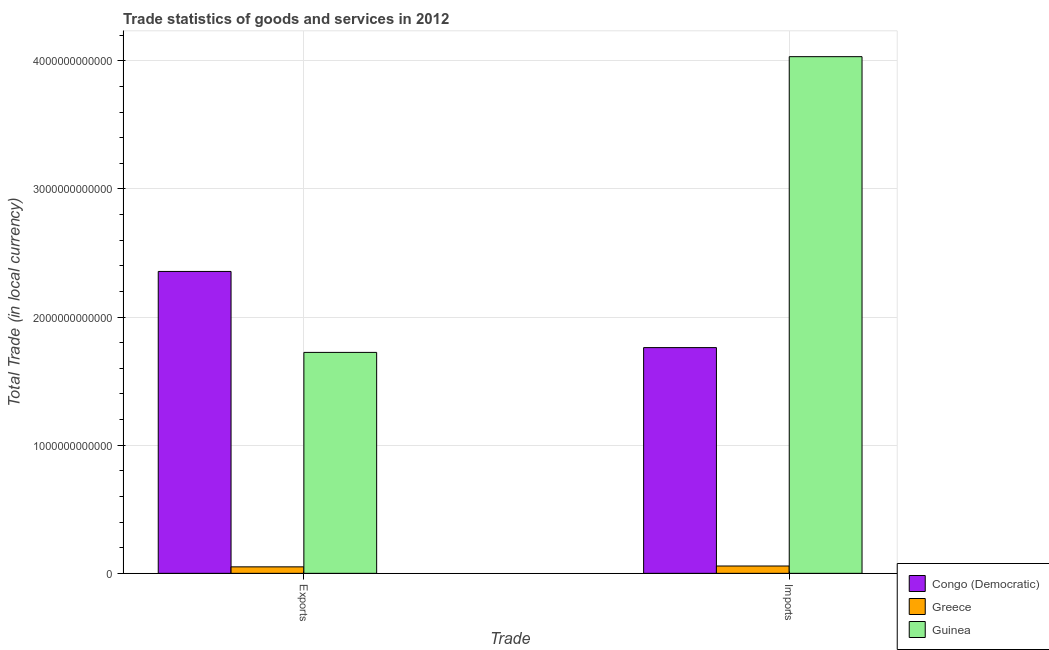How many different coloured bars are there?
Provide a short and direct response. 3. Are the number of bars per tick equal to the number of legend labels?
Provide a succinct answer. Yes. How many bars are there on the 1st tick from the left?
Give a very brief answer. 3. What is the label of the 2nd group of bars from the left?
Provide a succinct answer. Imports. What is the imports of goods and services in Greece?
Provide a succinct answer. 5.72e+1. Across all countries, what is the maximum imports of goods and services?
Your response must be concise. 4.03e+12. Across all countries, what is the minimum imports of goods and services?
Ensure brevity in your answer.  5.72e+1. In which country was the imports of goods and services maximum?
Offer a very short reply. Guinea. In which country was the export of goods and services minimum?
Offer a very short reply. Greece. What is the total imports of goods and services in the graph?
Provide a succinct answer. 5.85e+12. What is the difference between the imports of goods and services in Greece and that in Congo (Democratic)?
Give a very brief answer. -1.70e+12. What is the difference between the export of goods and services in Greece and the imports of goods and services in Guinea?
Offer a very short reply. -3.98e+12. What is the average export of goods and services per country?
Keep it short and to the point. 1.38e+12. What is the difference between the export of goods and services and imports of goods and services in Guinea?
Keep it short and to the point. -2.31e+12. In how many countries, is the export of goods and services greater than 2000000000000 LCU?
Keep it short and to the point. 1. What is the ratio of the export of goods and services in Greece to that in Congo (Democratic)?
Provide a short and direct response. 0.02. In how many countries, is the export of goods and services greater than the average export of goods and services taken over all countries?
Your answer should be compact. 2. What does the 1st bar from the left in Exports represents?
Keep it short and to the point. Congo (Democratic). How many bars are there?
Give a very brief answer. 6. Are all the bars in the graph horizontal?
Your response must be concise. No. What is the difference between two consecutive major ticks on the Y-axis?
Provide a succinct answer. 1.00e+12. Does the graph contain any zero values?
Offer a terse response. No. Does the graph contain grids?
Your answer should be compact. Yes. How many legend labels are there?
Ensure brevity in your answer.  3. What is the title of the graph?
Ensure brevity in your answer.  Trade statistics of goods and services in 2012. What is the label or title of the X-axis?
Offer a terse response. Trade. What is the label or title of the Y-axis?
Provide a short and direct response. Total Trade (in local currency). What is the Total Trade (in local currency) of Congo (Democratic) in Exports?
Offer a terse response. 2.36e+12. What is the Total Trade (in local currency) in Greece in Exports?
Ensure brevity in your answer.  5.06e+1. What is the Total Trade (in local currency) of Guinea in Exports?
Offer a very short reply. 1.72e+12. What is the Total Trade (in local currency) in Congo (Democratic) in Imports?
Offer a very short reply. 1.76e+12. What is the Total Trade (in local currency) in Greece in Imports?
Your response must be concise. 5.72e+1. What is the Total Trade (in local currency) in Guinea in Imports?
Provide a succinct answer. 4.03e+12. Across all Trade, what is the maximum Total Trade (in local currency) in Congo (Democratic)?
Give a very brief answer. 2.36e+12. Across all Trade, what is the maximum Total Trade (in local currency) in Greece?
Keep it short and to the point. 5.72e+1. Across all Trade, what is the maximum Total Trade (in local currency) of Guinea?
Your response must be concise. 4.03e+12. Across all Trade, what is the minimum Total Trade (in local currency) in Congo (Democratic)?
Provide a short and direct response. 1.76e+12. Across all Trade, what is the minimum Total Trade (in local currency) in Greece?
Your response must be concise. 5.06e+1. Across all Trade, what is the minimum Total Trade (in local currency) of Guinea?
Keep it short and to the point. 1.72e+12. What is the total Total Trade (in local currency) of Congo (Democratic) in the graph?
Make the answer very short. 4.12e+12. What is the total Total Trade (in local currency) of Greece in the graph?
Your answer should be very brief. 1.08e+11. What is the total Total Trade (in local currency) in Guinea in the graph?
Keep it short and to the point. 5.76e+12. What is the difference between the Total Trade (in local currency) of Congo (Democratic) in Exports and that in Imports?
Your answer should be compact. 5.94e+11. What is the difference between the Total Trade (in local currency) of Greece in Exports and that in Imports?
Offer a terse response. -6.61e+09. What is the difference between the Total Trade (in local currency) in Guinea in Exports and that in Imports?
Ensure brevity in your answer.  -2.31e+12. What is the difference between the Total Trade (in local currency) of Congo (Democratic) in Exports and the Total Trade (in local currency) of Greece in Imports?
Your response must be concise. 2.30e+12. What is the difference between the Total Trade (in local currency) of Congo (Democratic) in Exports and the Total Trade (in local currency) of Guinea in Imports?
Your response must be concise. -1.68e+12. What is the difference between the Total Trade (in local currency) of Greece in Exports and the Total Trade (in local currency) of Guinea in Imports?
Provide a succinct answer. -3.98e+12. What is the average Total Trade (in local currency) in Congo (Democratic) per Trade?
Offer a very short reply. 2.06e+12. What is the average Total Trade (in local currency) in Greece per Trade?
Your response must be concise. 5.39e+1. What is the average Total Trade (in local currency) in Guinea per Trade?
Offer a terse response. 2.88e+12. What is the difference between the Total Trade (in local currency) in Congo (Democratic) and Total Trade (in local currency) in Greece in Exports?
Offer a very short reply. 2.31e+12. What is the difference between the Total Trade (in local currency) in Congo (Democratic) and Total Trade (in local currency) in Guinea in Exports?
Make the answer very short. 6.32e+11. What is the difference between the Total Trade (in local currency) in Greece and Total Trade (in local currency) in Guinea in Exports?
Give a very brief answer. -1.67e+12. What is the difference between the Total Trade (in local currency) in Congo (Democratic) and Total Trade (in local currency) in Greece in Imports?
Offer a terse response. 1.70e+12. What is the difference between the Total Trade (in local currency) in Congo (Democratic) and Total Trade (in local currency) in Guinea in Imports?
Provide a short and direct response. -2.27e+12. What is the difference between the Total Trade (in local currency) of Greece and Total Trade (in local currency) of Guinea in Imports?
Provide a short and direct response. -3.98e+12. What is the ratio of the Total Trade (in local currency) in Congo (Democratic) in Exports to that in Imports?
Your answer should be very brief. 1.34. What is the ratio of the Total Trade (in local currency) of Greece in Exports to that in Imports?
Give a very brief answer. 0.88. What is the ratio of the Total Trade (in local currency) of Guinea in Exports to that in Imports?
Provide a succinct answer. 0.43. What is the difference between the highest and the second highest Total Trade (in local currency) in Congo (Democratic)?
Provide a succinct answer. 5.94e+11. What is the difference between the highest and the second highest Total Trade (in local currency) of Greece?
Provide a short and direct response. 6.61e+09. What is the difference between the highest and the second highest Total Trade (in local currency) of Guinea?
Provide a short and direct response. 2.31e+12. What is the difference between the highest and the lowest Total Trade (in local currency) in Congo (Democratic)?
Offer a terse response. 5.94e+11. What is the difference between the highest and the lowest Total Trade (in local currency) of Greece?
Keep it short and to the point. 6.61e+09. What is the difference between the highest and the lowest Total Trade (in local currency) of Guinea?
Offer a terse response. 2.31e+12. 